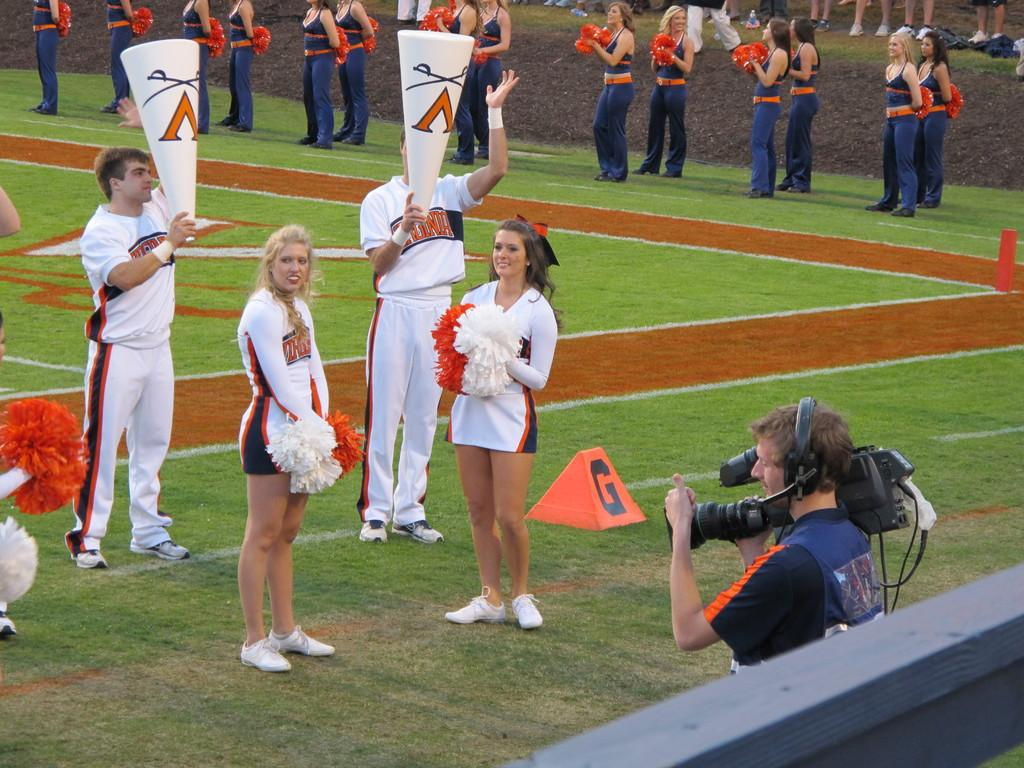<image>
Summarize the visual content of the image. a group of cheerleaders on the field with the letter G on the grass 